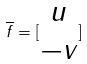Convert formula to latex. <formula><loc_0><loc_0><loc_500><loc_500>\overline { f } = [ \begin{matrix} u \\ - v \end{matrix} ]</formula> 